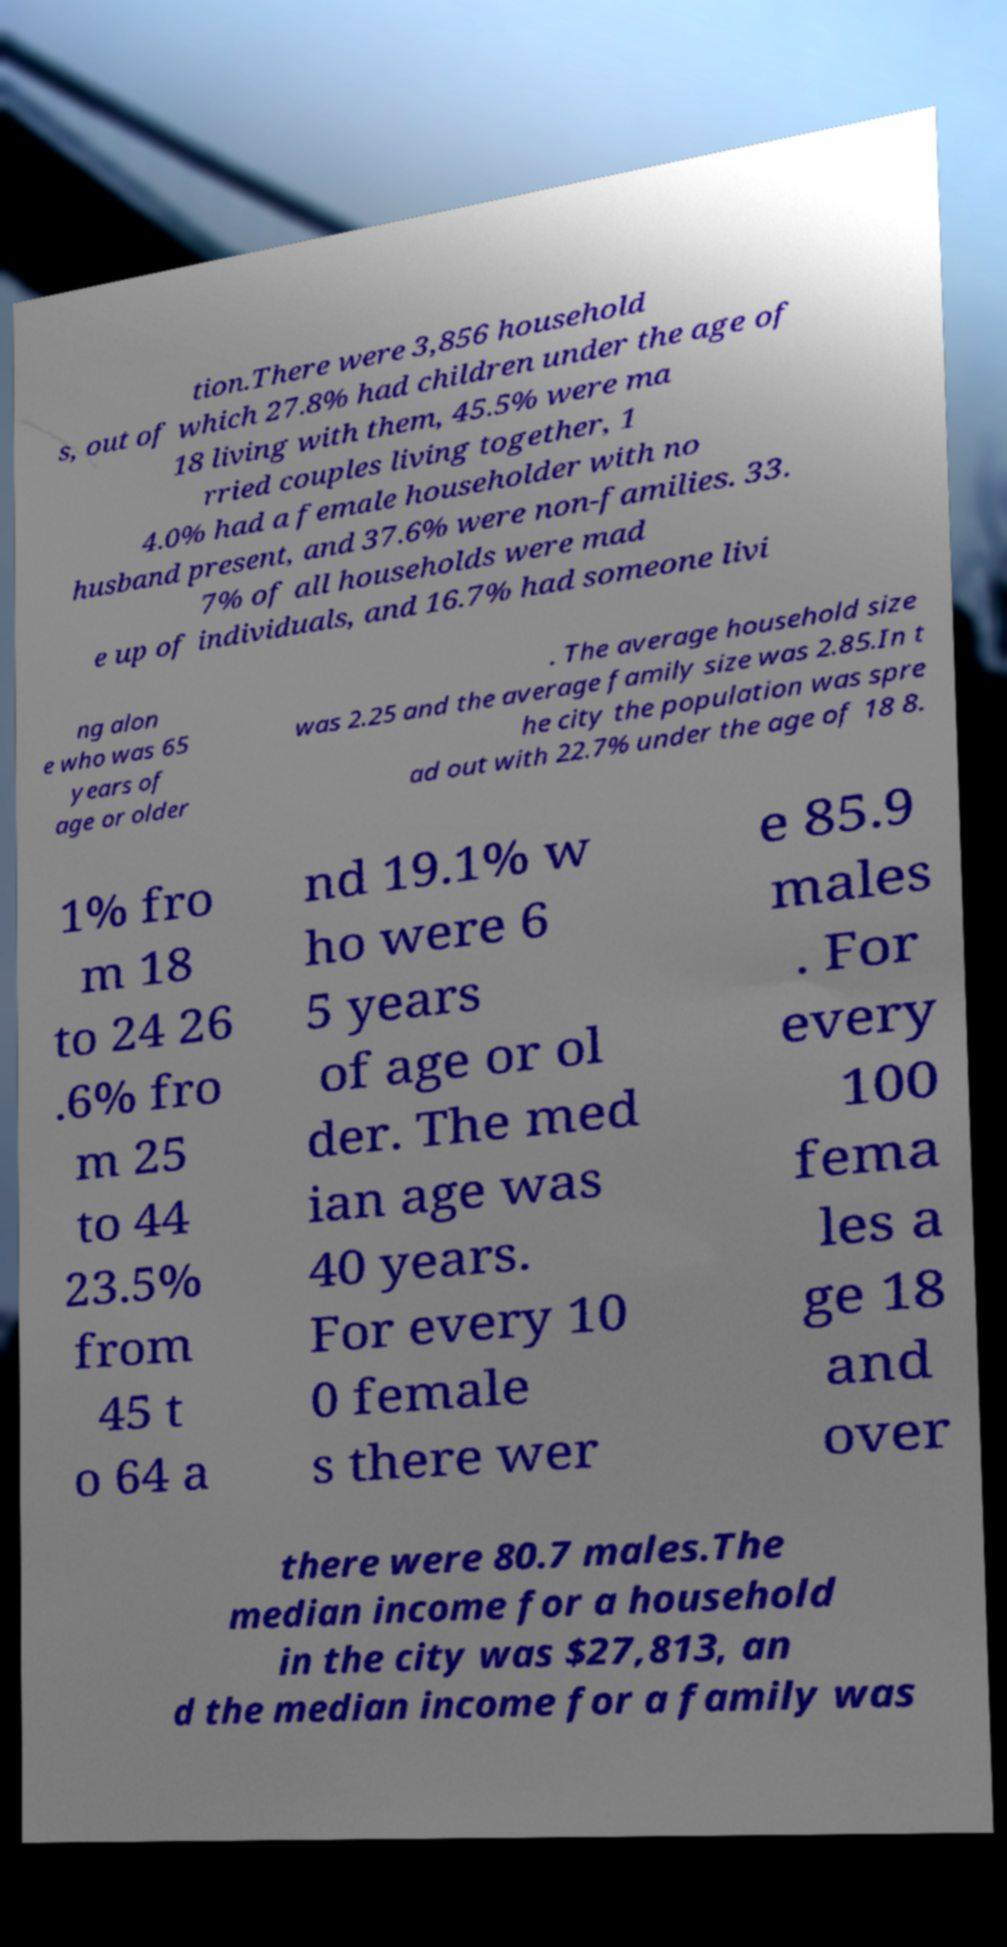I need the written content from this picture converted into text. Can you do that? tion.There were 3,856 household s, out of which 27.8% had children under the age of 18 living with them, 45.5% were ma rried couples living together, 1 4.0% had a female householder with no husband present, and 37.6% were non-families. 33. 7% of all households were mad e up of individuals, and 16.7% had someone livi ng alon e who was 65 years of age or older . The average household size was 2.25 and the average family size was 2.85.In t he city the population was spre ad out with 22.7% under the age of 18 8. 1% fro m 18 to 24 26 .6% fro m 25 to 44 23.5% from 45 t o 64 a nd 19.1% w ho were 6 5 years of age or ol der. The med ian age was 40 years. For every 10 0 female s there wer e 85.9 males . For every 100 fema les a ge 18 and over there were 80.7 males.The median income for a household in the city was $27,813, an d the median income for a family was 